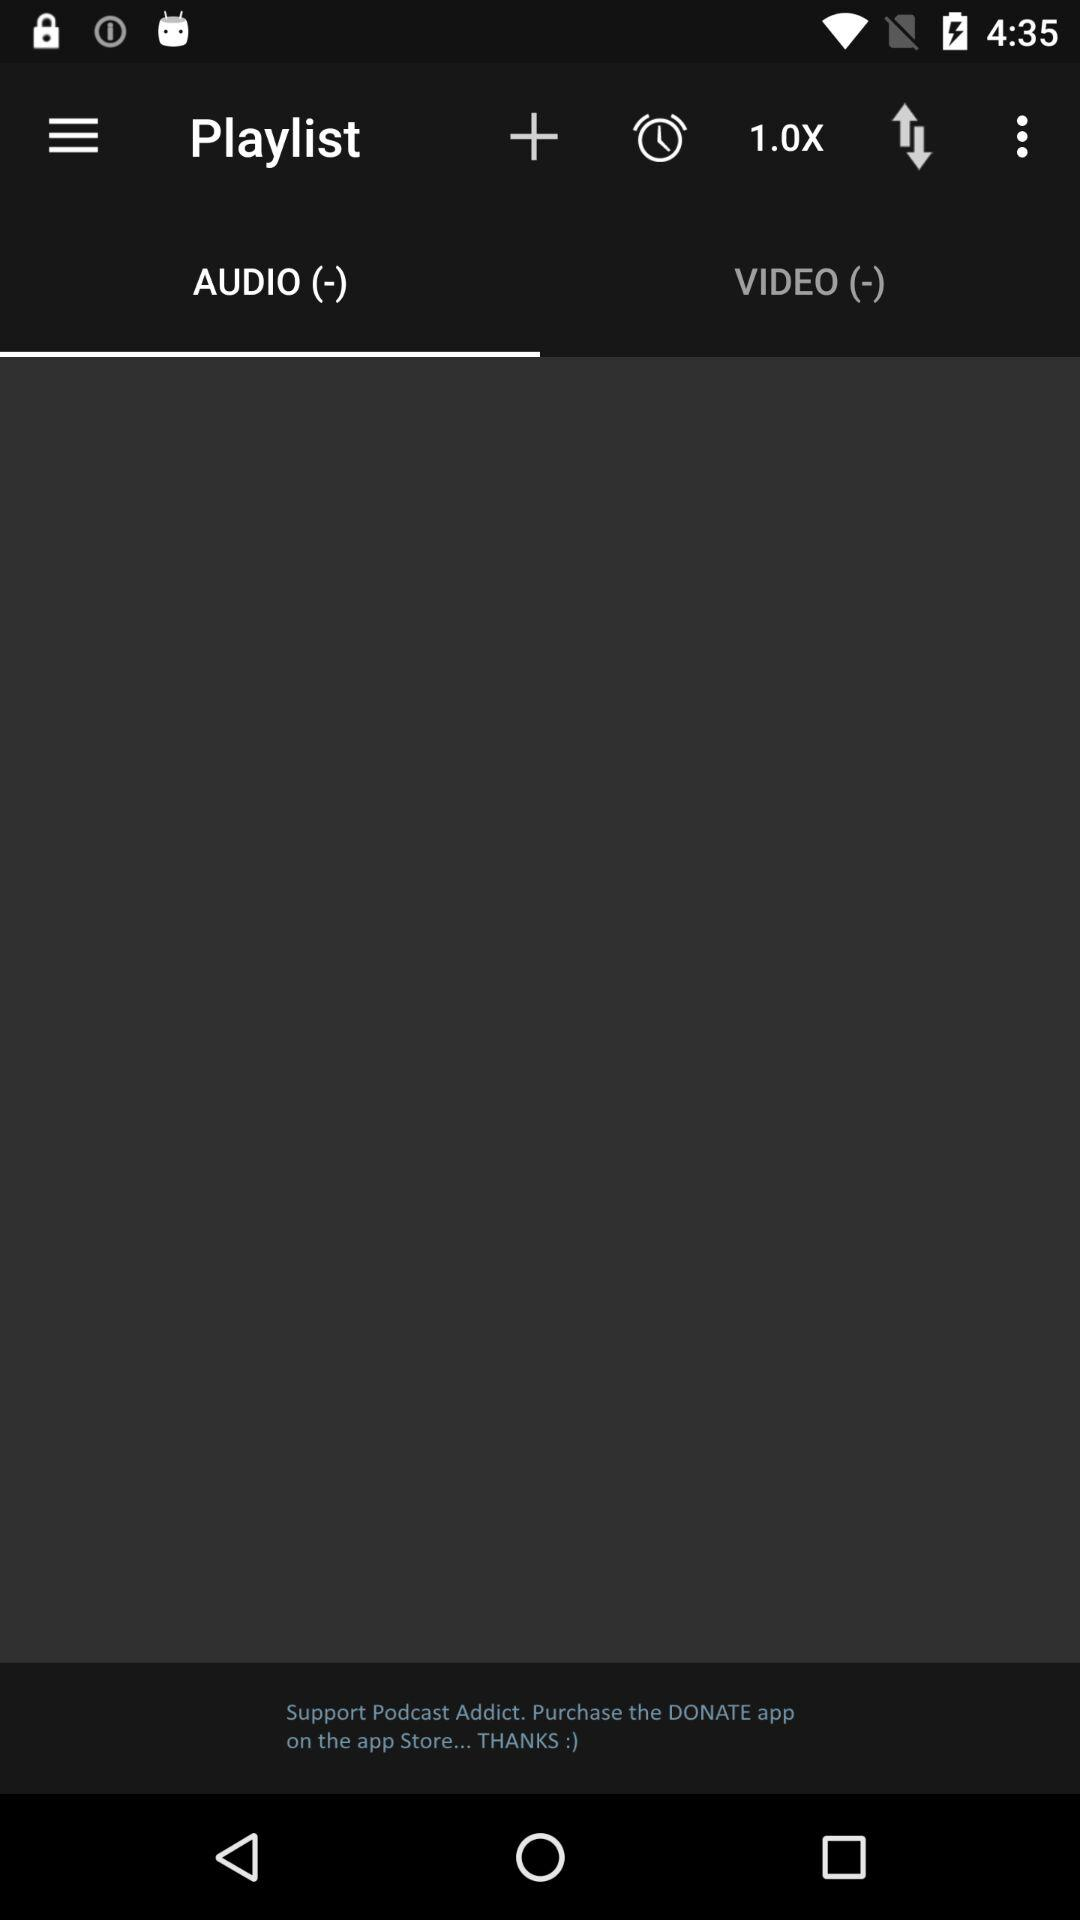Which tab is selected? The selected tab is "AUDIO (-)". 